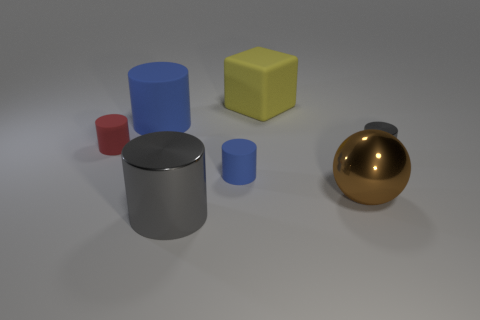What is the size of the other object that is the same color as the small shiny thing?
Offer a terse response. Large. What number of big objects are metallic balls or green shiny cylinders?
Offer a very short reply. 1. What color is the other metal thing that is the same shape as the tiny gray object?
Your answer should be compact. Gray. Does the red matte thing have the same size as the brown shiny thing?
Your response must be concise. No. What number of objects are tiny yellow rubber cylinders or blue rubber cylinders behind the small gray metallic thing?
Keep it short and to the point. 1. There is a big matte object on the left side of the gray object in front of the small metal object; what color is it?
Your answer should be compact. Blue. Does the small matte thing that is on the right side of the red cylinder have the same color as the big matte cylinder?
Keep it short and to the point. Yes. What is the gray cylinder that is on the left side of the shiny ball made of?
Make the answer very short. Metal. How big is the yellow rubber thing?
Provide a succinct answer. Large. Is the material of the small cylinder right of the brown sphere the same as the large ball?
Keep it short and to the point. Yes. 